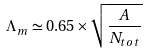Convert formula to latex. <formula><loc_0><loc_0><loc_500><loc_500>\Lambda _ { m } \simeq 0 . 6 5 \times \sqrt { \frac { A } { N _ { t o t } } }</formula> 